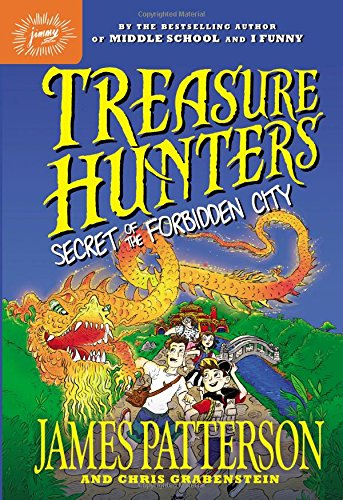Who is the author of this book? The book is authored by James Patterson, a prolific writer known for his engaging and suspenseful storylines. 